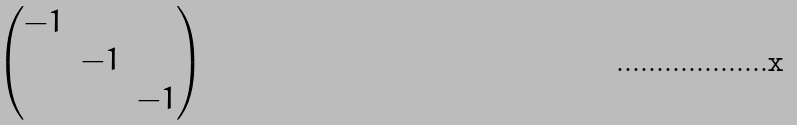Convert formula to latex. <formula><loc_0><loc_0><loc_500><loc_500>\begin{pmatrix} - 1 & & \\ & - 1 & \\ & & - 1 \end{pmatrix}</formula> 